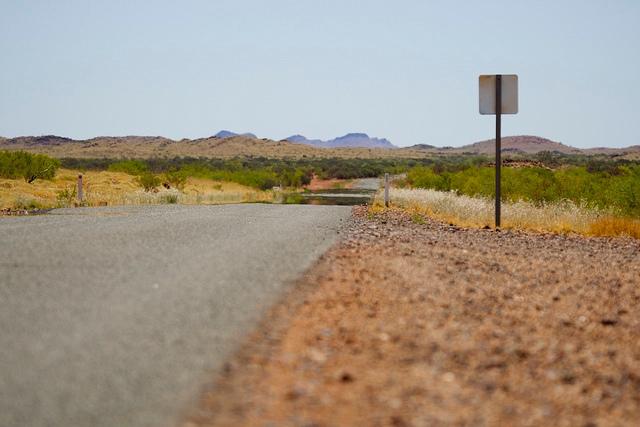Does it look hot or cold?
Keep it brief. Hot. How far is the nearest town?
Keep it brief. 100 miles. Is there a speed limit for cars on this road?
Be succinct. Yes. 